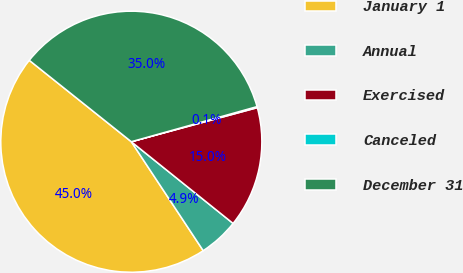<chart> <loc_0><loc_0><loc_500><loc_500><pie_chart><fcel>January 1<fcel>Annual<fcel>Exercised<fcel>Canceled<fcel>December 31<nl><fcel>45.0%<fcel>4.95%<fcel>14.97%<fcel>0.13%<fcel>34.95%<nl></chart> 